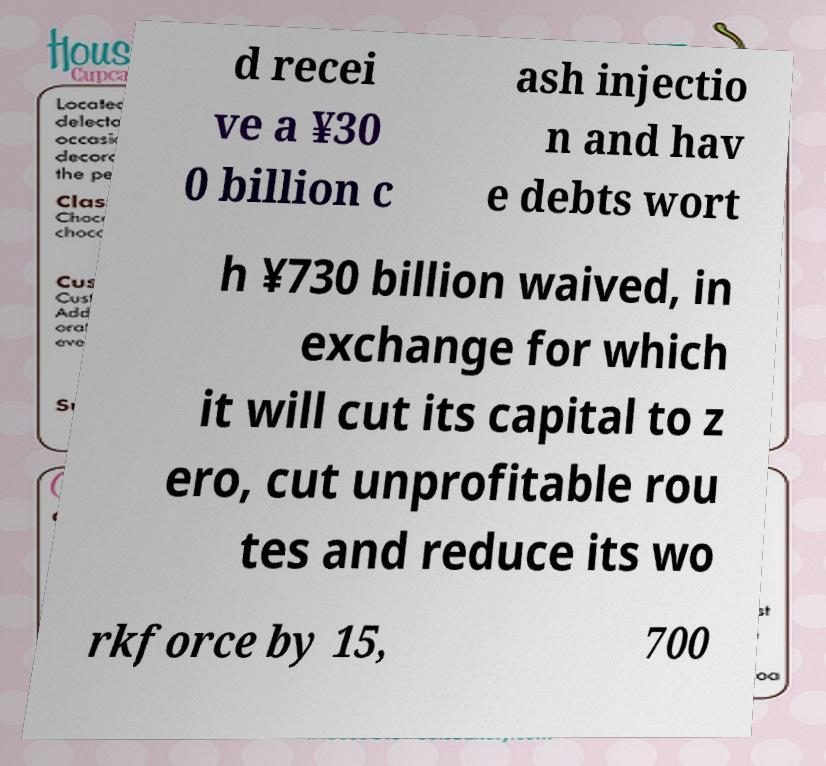Could you extract and type out the text from this image? d recei ve a ¥30 0 billion c ash injectio n and hav e debts wort h ¥730 billion waived, in exchange for which it will cut its capital to z ero, cut unprofitable rou tes and reduce its wo rkforce by 15, 700 